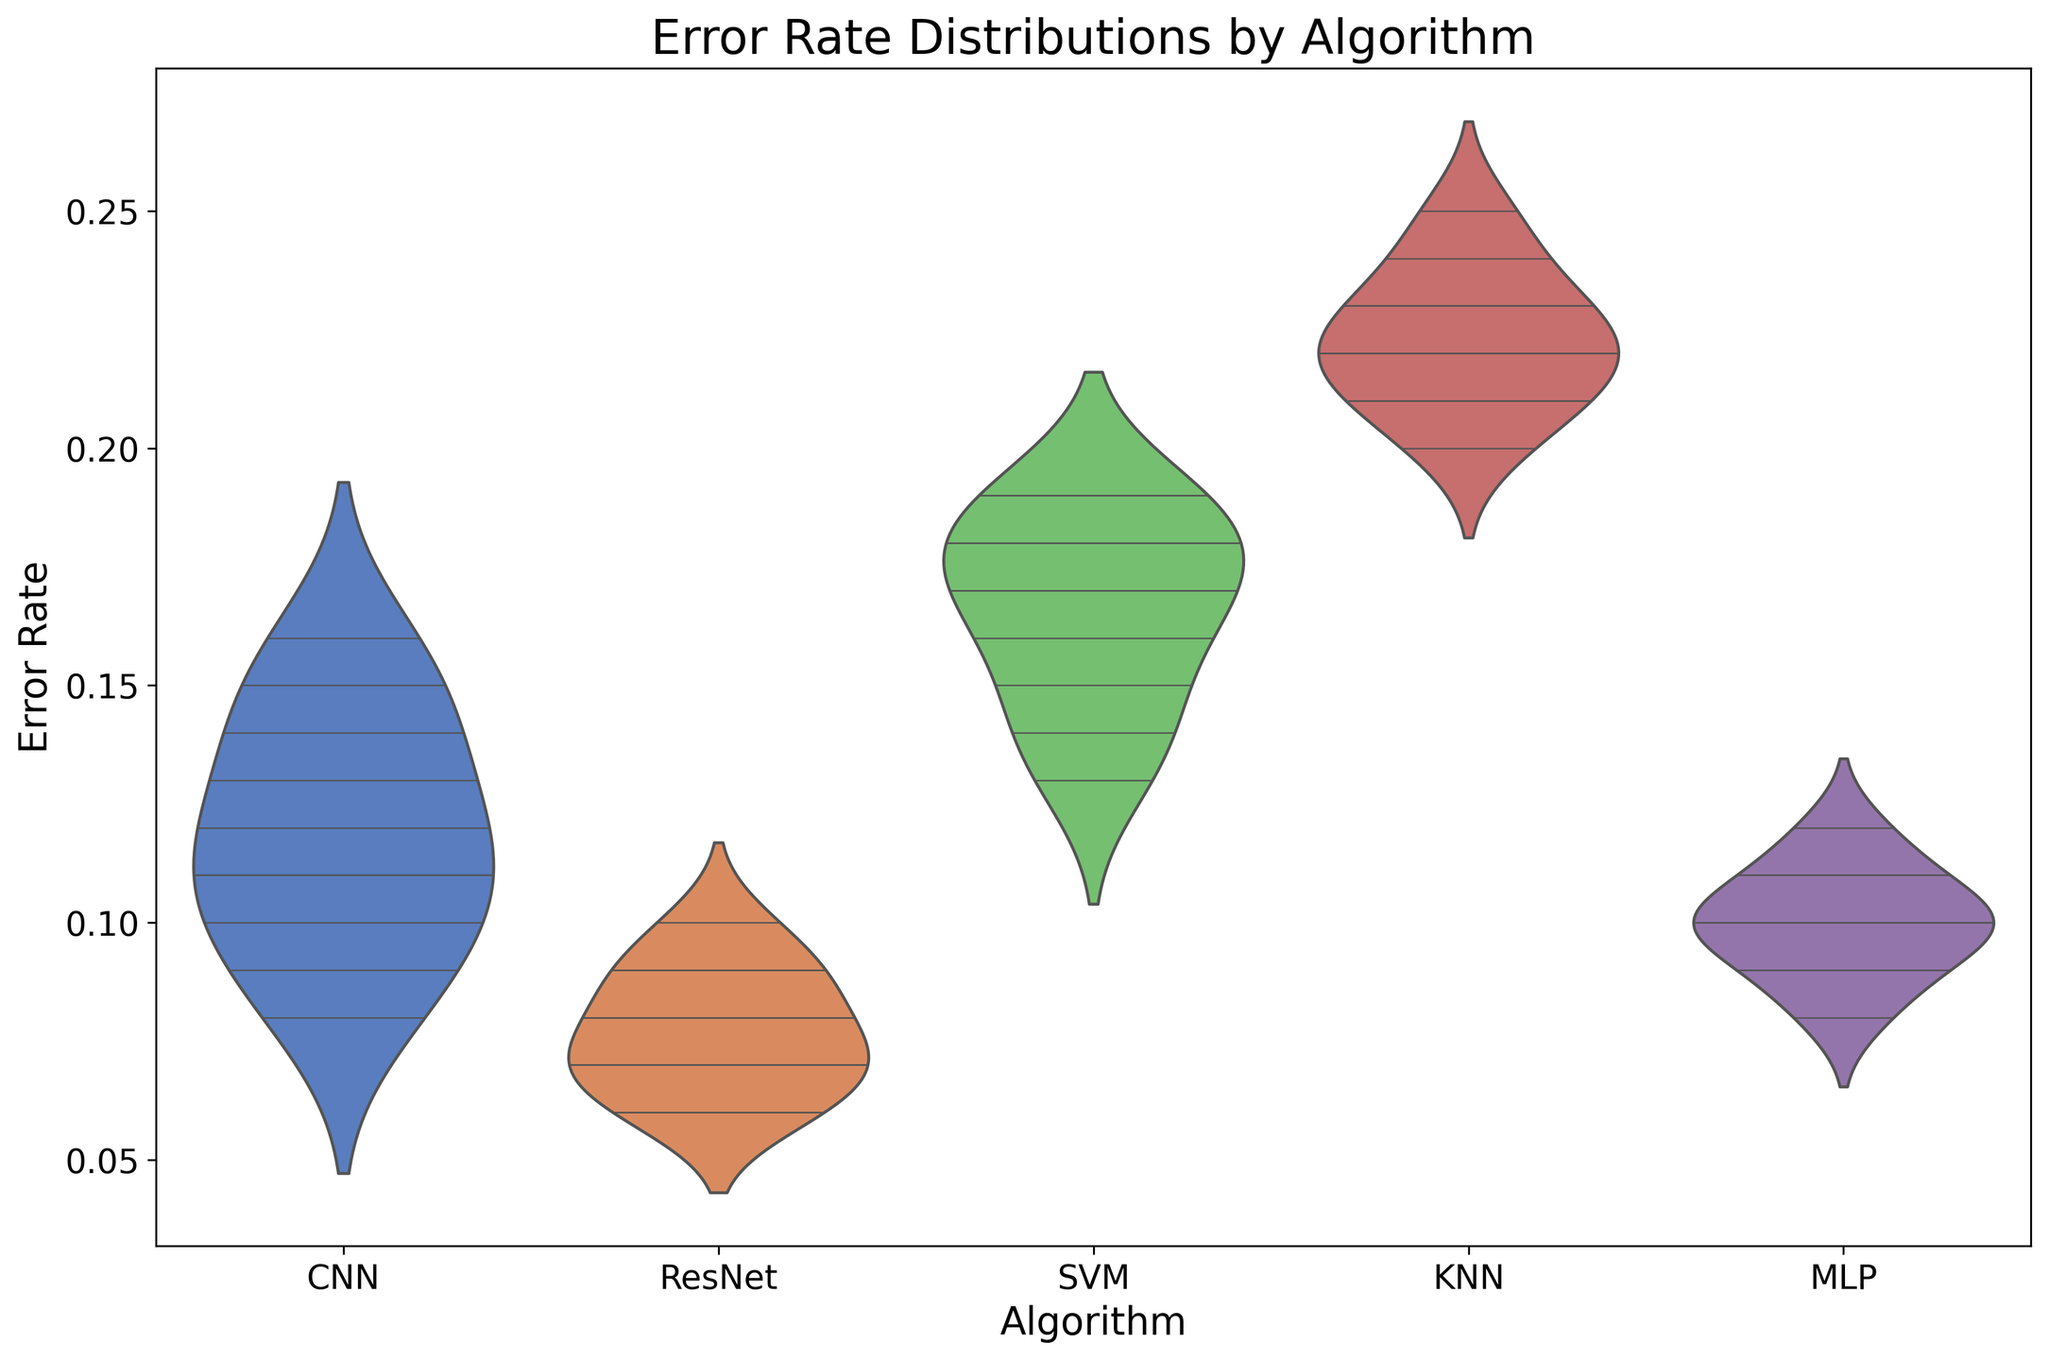What does the shape of the violin plot for the CNN algorithm suggest about its error rate distribution? The width of the violin plot at any given y-axis position indicates the density of the error rates at that value. For CNN, it shows that the error rate distribution is relatively spread around the lower values (with a peak around 0.11), indicating less error diversity compared to other algorithms.
Answer: The error rate distribution for CNN is relatively concentrated around lower values Which algorithm has the lowest median error rate? By inspecting the central white line (representing the median) in each violin plot, it is evident that the ResNet algorithm has the lowest median error rate.
Answer: ResNet How do the distributions of error rates for KNN and SVM compare? The KNN algorithm has a higher and wider distribution of error rates compared to SVM, indicating that KNN typically has higher error rates and more variability. Both distributions also show higher peaks at their respective error rates.
Answer: KNN has higher and wider error distributions compared to SVM Which algorithm shows the most variability in its error rate? Variability can be determined by the width and spread of the violin plot. The KNN algorithm shows the widest and most spread out violin plot, indicating the highest variability in error rates.
Answer: KNN What can you infer about the performance of MLP compared to CNN? By comparing the medians and the spread, MLP's error rate distribution is slightly lower and more compact than CNN's, suggesting that MLP overall performs slightly better with more consistent results.
Answer: MLP performs slightly better and more consistently than CNN 